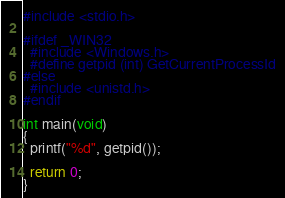Convert code to text. <code><loc_0><loc_0><loc_500><loc_500><_C_>#include <stdio.h>

#ifdef _WIN32
  #include <Windows.h>
  #define getpid (int) GetCurrentProcessId
#else
  #include <unistd.h>
#endif

int main(void)
{
  printf("%d", getpid());

  return 0;
}
</code> 